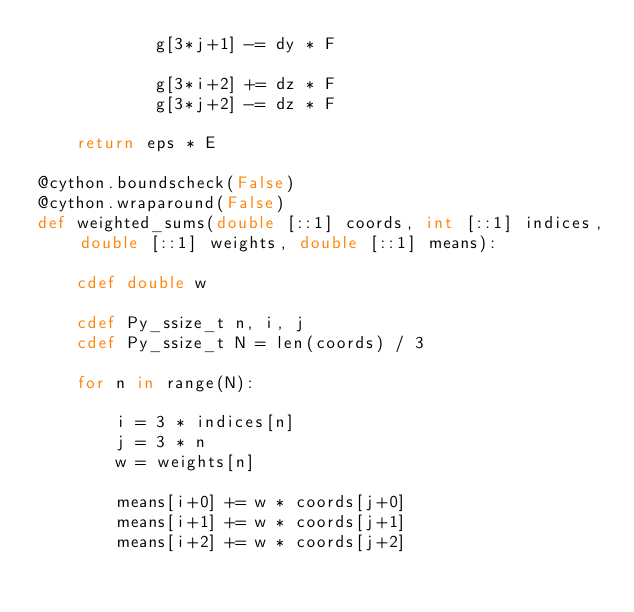Convert code to text. <code><loc_0><loc_0><loc_500><loc_500><_Cython_>            g[3*j+1] -= dy * F

            g[3*i+2] += dz * F
            g[3*j+2] -= dz * F

    return eps * E

@cython.boundscheck(False)
@cython.wraparound(False)
def weighted_sums(double [::1] coords, int [::1] indices, double [::1] weights, double [::1] means):

    cdef double w

    cdef Py_ssize_t n, i, j
    cdef Py_ssize_t N = len(coords) / 3
    
    for n in range(N):

        i = 3 * indices[n]
        j = 3 * n
        w = weights[n]

        means[i+0] += w * coords[j+0]
        means[i+1] += w * coords[j+1]
        means[i+2] += w * coords[j+2]

</code> 